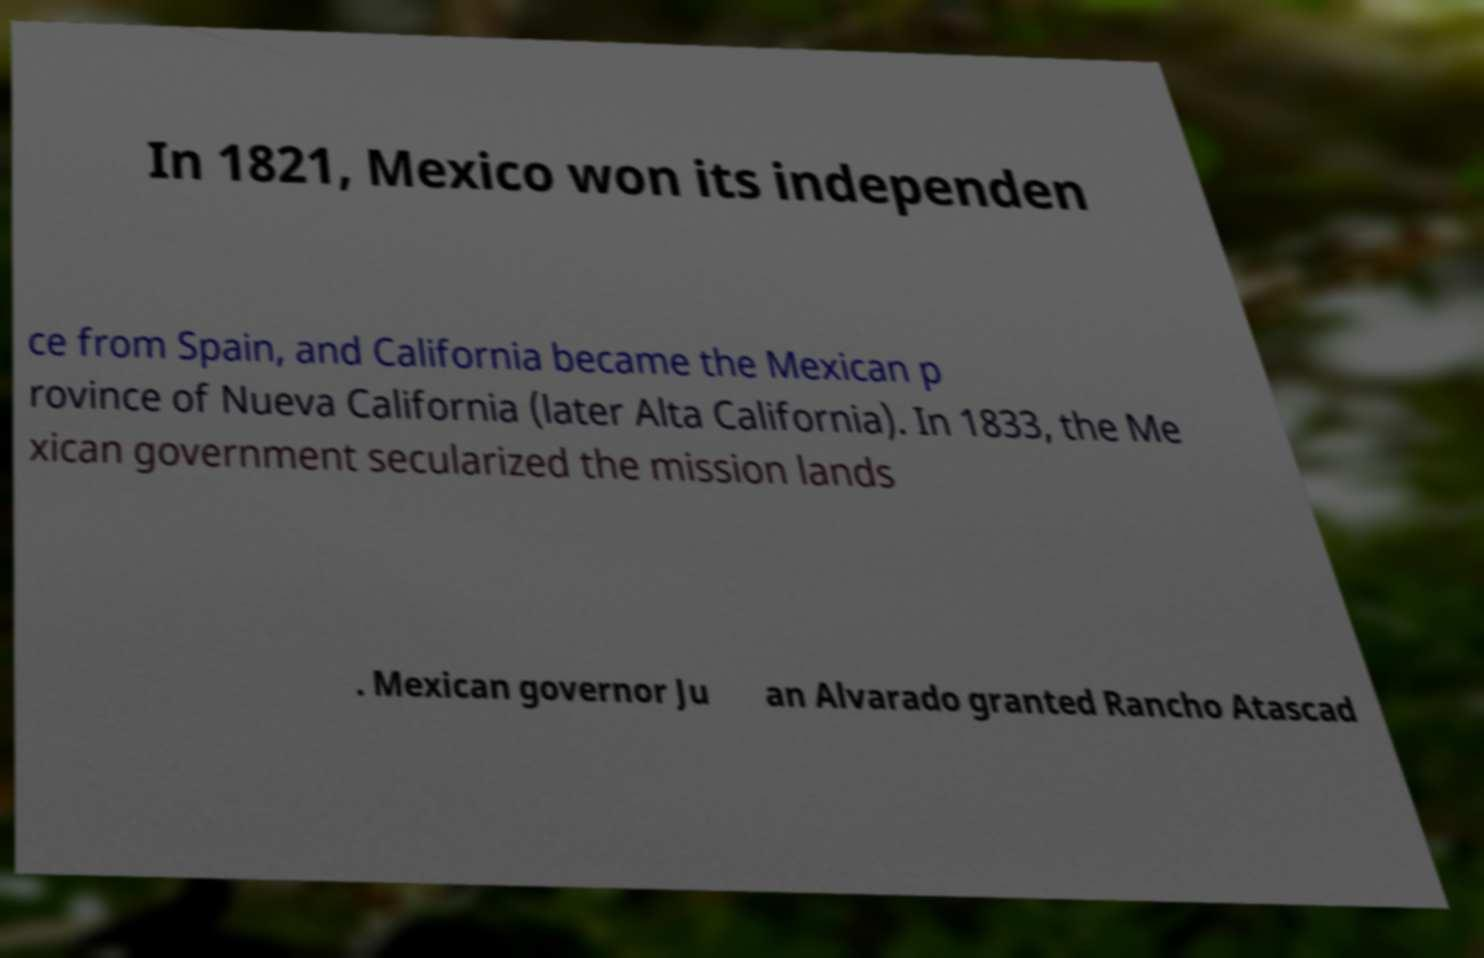Can you read and provide the text displayed in the image?This photo seems to have some interesting text. Can you extract and type it out for me? In 1821, Mexico won its independen ce from Spain, and California became the Mexican p rovince of Nueva California (later Alta California). In 1833, the Me xican government secularized the mission lands . Mexican governor Ju an Alvarado granted Rancho Atascad 